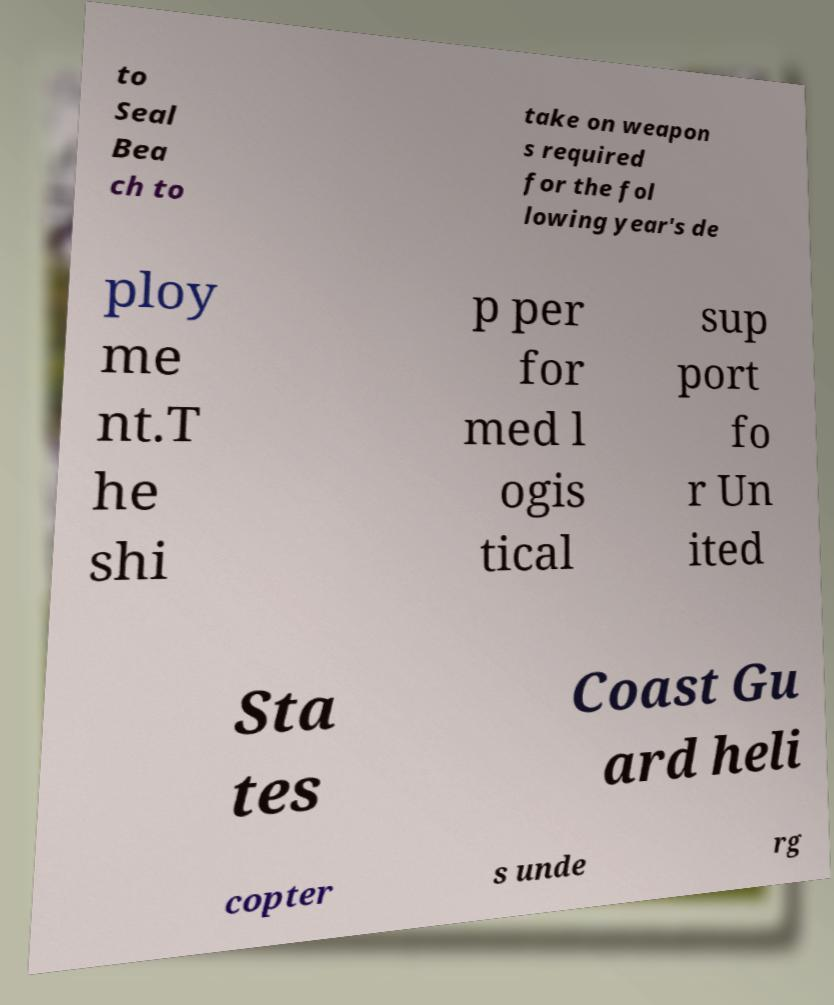Could you extract and type out the text from this image? to Seal Bea ch to take on weapon s required for the fol lowing year's de ploy me nt.T he shi p per for med l ogis tical sup port fo r Un ited Sta tes Coast Gu ard heli copter s unde rg 